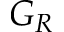Convert formula to latex. <formula><loc_0><loc_0><loc_500><loc_500>G _ { R }</formula> 